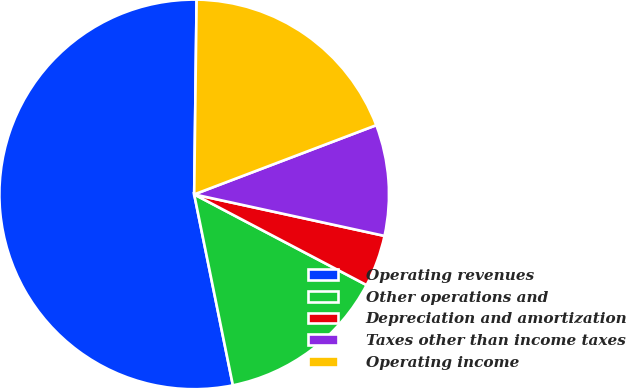Convert chart to OTSL. <chart><loc_0><loc_0><loc_500><loc_500><pie_chart><fcel>Operating revenues<fcel>Other operations and<fcel>Depreciation and amortization<fcel>Taxes other than income taxes<fcel>Operating income<nl><fcel>53.38%<fcel>14.11%<fcel>4.29%<fcel>9.2%<fcel>19.02%<nl></chart> 